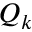Convert formula to latex. <formula><loc_0><loc_0><loc_500><loc_500>Q _ { k }</formula> 